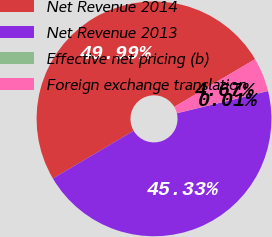Convert chart. <chart><loc_0><loc_0><loc_500><loc_500><pie_chart><fcel>Net Revenue 2014<fcel>Net Revenue 2013<fcel>Effective net pricing (b)<fcel>Foreign exchange translation<nl><fcel>49.99%<fcel>45.33%<fcel>0.01%<fcel>4.67%<nl></chart> 